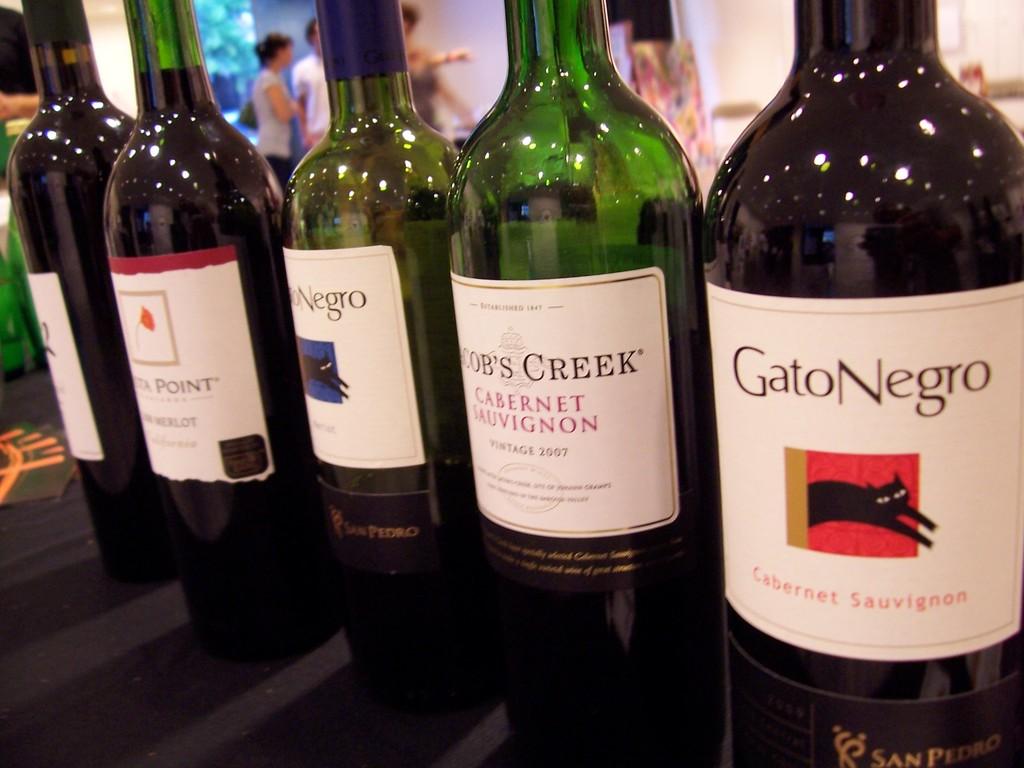What kind of wine is this?
Your answer should be very brief. Cabernet sauvignon. What is the name of the wine on the far right?
Your response must be concise. Gato negro. 